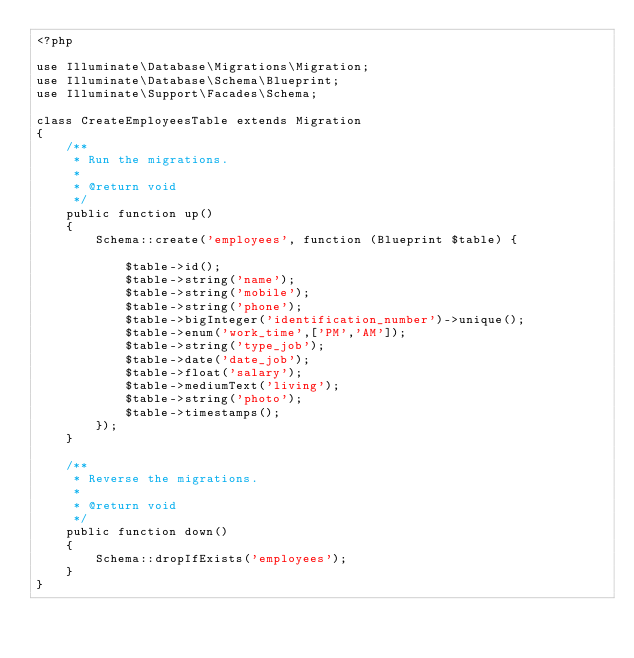Convert code to text. <code><loc_0><loc_0><loc_500><loc_500><_PHP_><?php

use Illuminate\Database\Migrations\Migration;
use Illuminate\Database\Schema\Blueprint;
use Illuminate\Support\Facades\Schema;

class CreateEmployeesTable extends Migration
{
    /**
     * Run the migrations.
     *
     * @return void
     */
    public function up()
    {
        Schema::create('employees', function (Blueprint $table) {

            $table->id();
            $table->string('name');
            $table->string('mobile');
            $table->string('phone');
            $table->bigInteger('identification_number')->unique();
            $table->enum('work_time',['PM','AM']);
            $table->string('type_job');
            $table->date('date_job');
            $table->float('salary');
            $table->mediumText('living');
            $table->string('photo');
            $table->timestamps();
        });
    }

    /**
     * Reverse the migrations.
     *
     * @return void
     */
    public function down()
    {
        Schema::dropIfExists('employees');
    }
}
</code> 